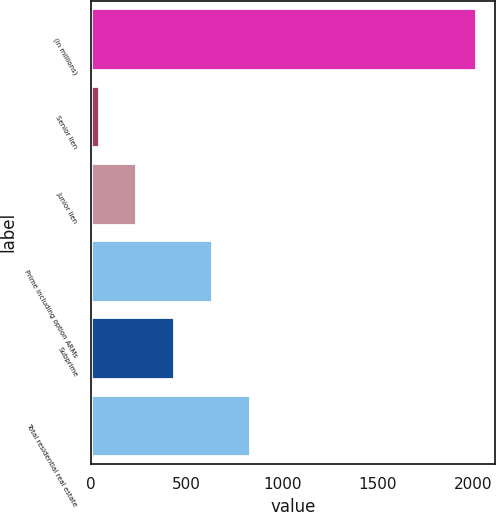Convert chart to OTSL. <chart><loc_0><loc_0><loc_500><loc_500><bar_chart><fcel>(in millions)<fcel>Senior lien<fcel>Junior lien<fcel>Prime including option ARMs<fcel>Subprime<fcel>Total residential real estate<nl><fcel>2013<fcel>40<fcel>237.3<fcel>631.9<fcel>434.6<fcel>829.2<nl></chart> 